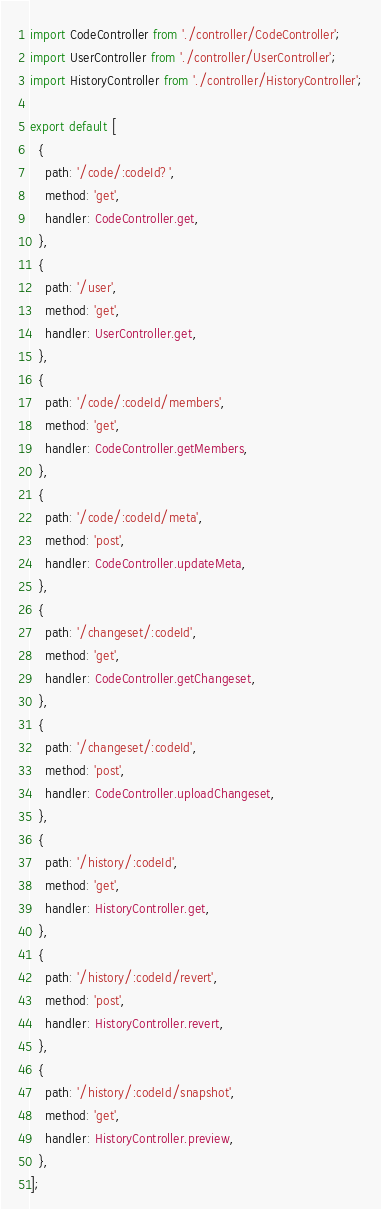<code> <loc_0><loc_0><loc_500><loc_500><_TypeScript_>import CodeController from './controller/CodeController';
import UserController from './controller/UserController';
import HistoryController from './controller/HistoryController';

export default [
  {
    path: '/code/:codeId?',
    method: 'get',
    handler: CodeController.get,
  },
  {
    path: '/user',
    method: 'get',
    handler: UserController.get,
  },
  {
    path: '/code/:codeId/members',
    method: 'get',
    handler: CodeController.getMembers,
  },
  {
    path: '/code/:codeId/meta',
    method: 'post',
    handler: CodeController.updateMeta,
  },
  {
    path: '/changeset/:codeId',
    method: 'get',
    handler: CodeController.getChangeset,
  },
  {
    path: '/changeset/:codeId',
    method: 'post',
    handler: CodeController.uploadChangeset,
  },
  {
    path: '/history/:codeId',
    method: 'get',
    handler: HistoryController.get,
  },
  {
    path: '/history/:codeId/revert',
    method: 'post',
    handler: HistoryController.revert,
  },
  {
    path: '/history/:codeId/snapshot',
    method: 'get',
    handler: HistoryController.preview,
  },
];
</code> 